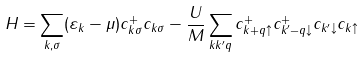Convert formula to latex. <formula><loc_0><loc_0><loc_500><loc_500>H = \sum _ { k , \sigma } ( \varepsilon _ { k } - \mu ) c ^ { + } _ { k \sigma } c _ { k \sigma } - \frac { U } { M } \sum _ { k k ^ { \prime } q } c ^ { + } _ { k + q \uparrow } c ^ { + } _ { k ^ { \prime } - q \downarrow } c _ { k ^ { \prime } \downarrow } c _ { k \uparrow }</formula> 